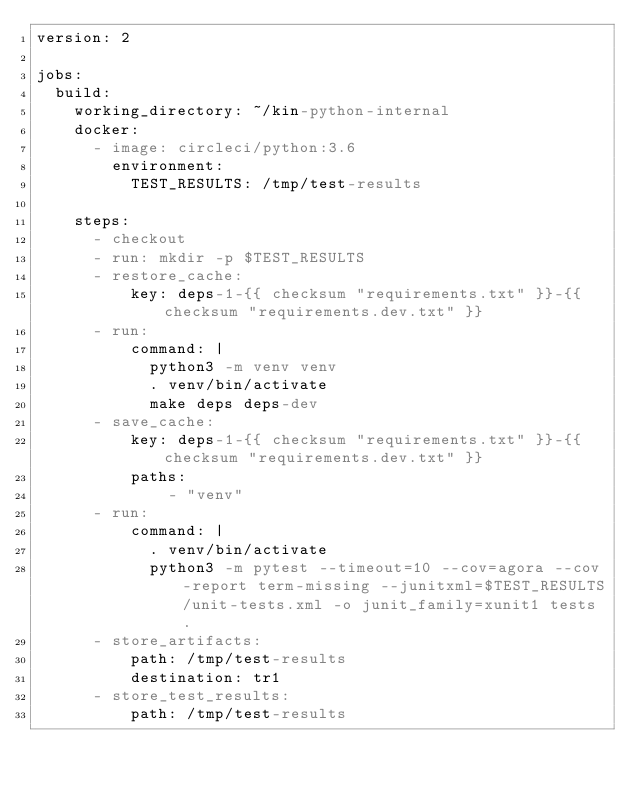Convert code to text. <code><loc_0><loc_0><loc_500><loc_500><_YAML_>version: 2

jobs:
  build:
    working_directory: ~/kin-python-internal
    docker:
      - image: circleci/python:3.6
        environment:
          TEST_RESULTS: /tmp/test-results

    steps:
      - checkout
      - run: mkdir -p $TEST_RESULTS
      - restore_cache:
          key: deps-1-{{ checksum "requirements.txt" }}-{{ checksum "requirements.dev.txt" }}
      - run:
          command: |
            python3 -m venv venv
            . venv/bin/activate
            make deps deps-dev
      - save_cache:
          key: deps-1-{{ checksum "requirements.txt" }}-{{ checksum "requirements.dev.txt" }}
          paths:
              - "venv"
      - run:
          command: |
            . venv/bin/activate
            python3 -m pytest --timeout=10 --cov=agora --cov-report term-missing --junitxml=$TEST_RESULTS/unit-tests.xml -o junit_family=xunit1 tests .
      - store_artifacts:
          path: /tmp/test-results
          destination: tr1
      - store_test_results:
          path: /tmp/test-results
</code> 